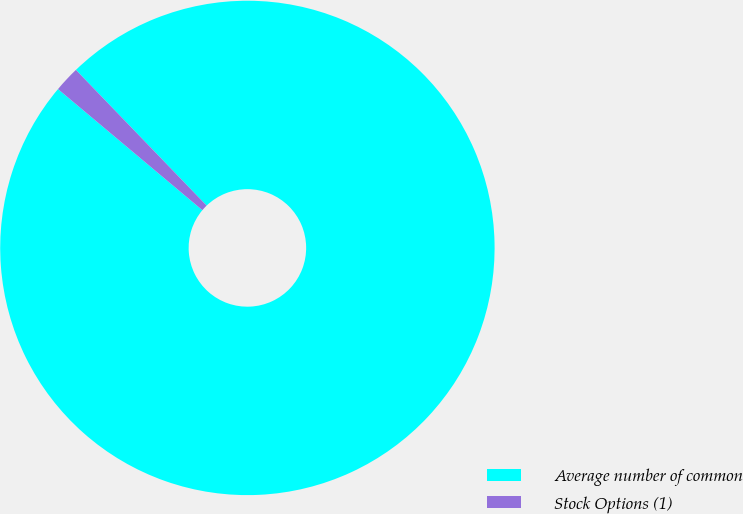Convert chart. <chart><loc_0><loc_0><loc_500><loc_500><pie_chart><fcel>Average number of common<fcel>Stock Options (1)<nl><fcel>98.31%<fcel>1.69%<nl></chart> 